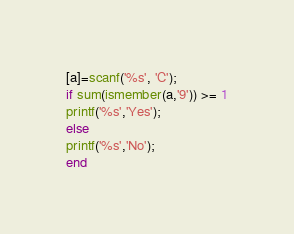<code> <loc_0><loc_0><loc_500><loc_500><_Octave_>[a]=scanf('%s', 'C');
if sum(ismember(a,'9')) >= 1
printf('%s','Yes');
else
printf('%s','No');
end</code> 